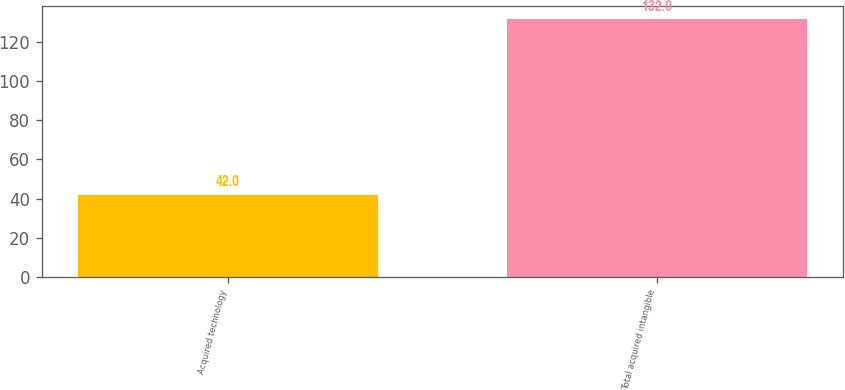Convert chart. <chart><loc_0><loc_0><loc_500><loc_500><bar_chart><fcel>Acquired technology<fcel>Total acquired intangible<nl><fcel>42<fcel>132<nl></chart> 